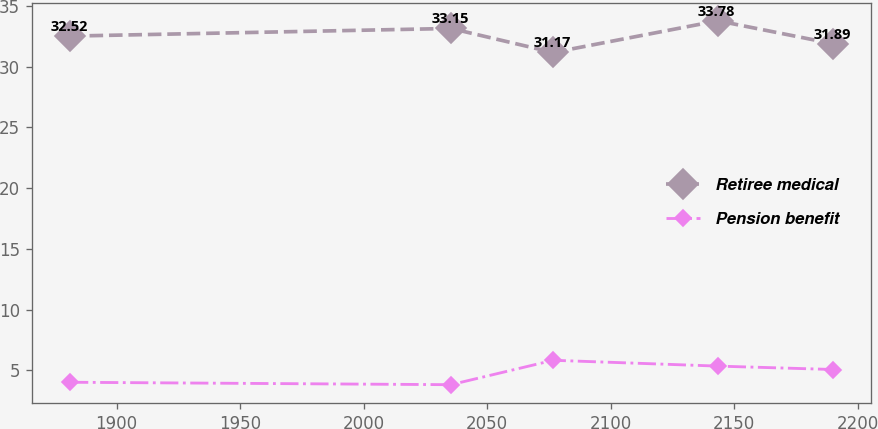<chart> <loc_0><loc_0><loc_500><loc_500><line_chart><ecel><fcel>Retiree medical<fcel>Pension benefit<nl><fcel>1881.22<fcel>32.52<fcel>4.02<nl><fcel>2035.34<fcel>33.15<fcel>3.82<nl><fcel>2076.7<fcel>31.17<fcel>5.83<nl><fcel>2143.32<fcel>33.78<fcel>5.35<nl><fcel>2190.06<fcel>31.89<fcel>5.07<nl></chart> 